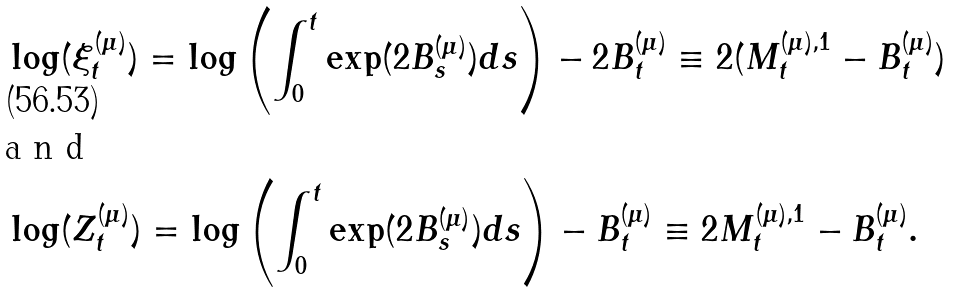Convert formula to latex. <formula><loc_0><loc_0><loc_500><loc_500>& \log ( \xi ^ { ( \mu ) } _ { t } ) = \log \left ( \int _ { 0 } ^ { t } \exp ( 2 B ^ { ( \mu ) } _ { s } ) d s \right ) - 2 B ^ { ( \mu ) } _ { t } \equiv 2 ( M ^ { ( \mu ) , 1 } _ { t } - B ^ { ( \mu ) } _ { t } ) \\ \intertext { a n d } & \log ( Z ^ { ( \mu ) } _ { t } ) = \log \left ( \int _ { 0 } ^ { t } \exp ( 2 B ^ { ( \mu ) } _ { s } ) d s \right ) - B ^ { ( \mu ) } _ { t } \equiv 2 M ^ { ( \mu ) , 1 } _ { t } - B ^ { ( \mu ) } _ { t } .</formula> 